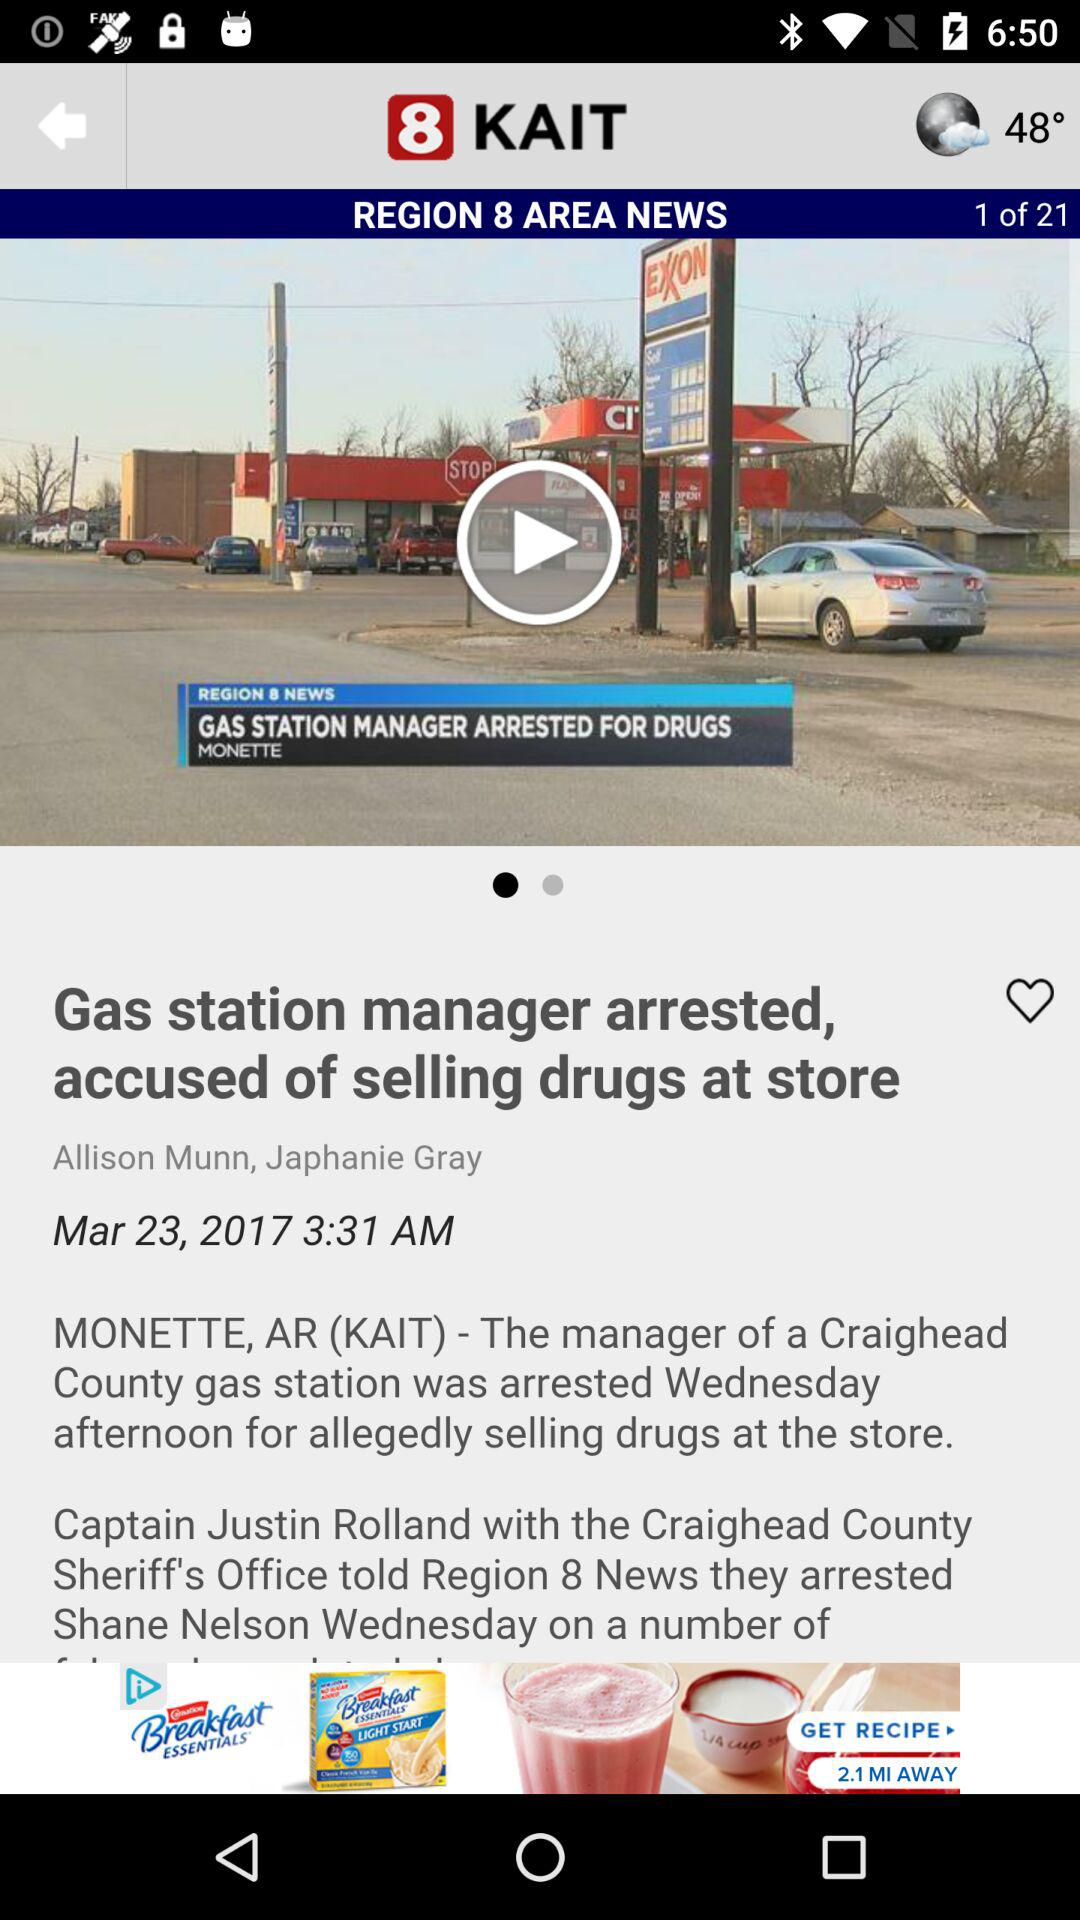What is the news channel name? The news channel name is 8 KAIT. 